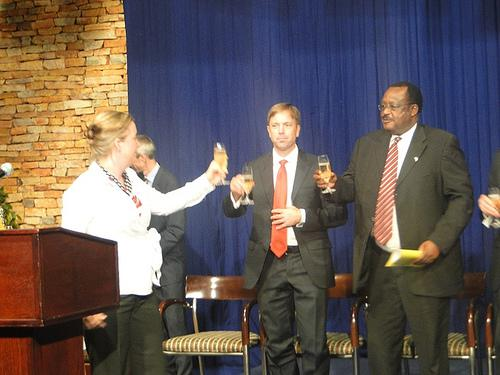Question: what pattern is the tie on the right?
Choices:
A. Plaid.
B. Stripes.
C. Polka dots.
D. Solid.
Answer with the letter. Answer: B Question: what are they raising?
Choices:
A. Glasses.
B. Candles.
C. Cell phones.
D. Spoons.
Answer with the letter. Answer: A Question: who wearing black pants?
Choices:
A. Nobody.
B. One man.
C. Everyone.
D. One little girl.
Answer with the letter. Answer: C Question: where is the microphone?
Choices:
A. Hanging from the ceiling.
B. In the speaker's hand.
C. On a post.
D. On the podium.
Answer with the letter. Answer: D 